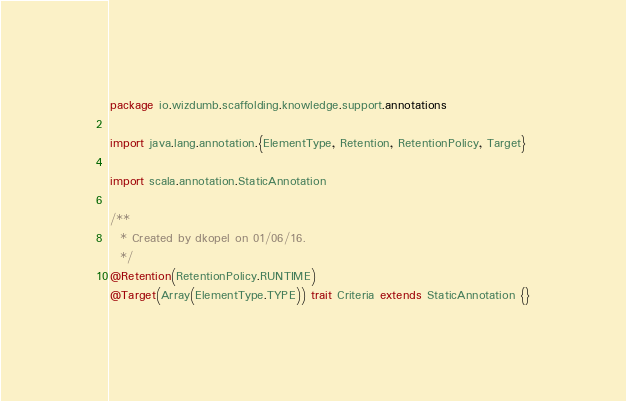Convert code to text. <code><loc_0><loc_0><loc_500><loc_500><_Scala_>package io.wizdumb.scaffolding.knowledge.support.annotations

import java.lang.annotation.{ElementType, Retention, RetentionPolicy, Target}

import scala.annotation.StaticAnnotation

/**
  * Created by dkopel on 01/06/16.
  */
@Retention(RetentionPolicy.RUNTIME)
@Target(Array(ElementType.TYPE)) trait Criteria extends StaticAnnotation {}</code> 